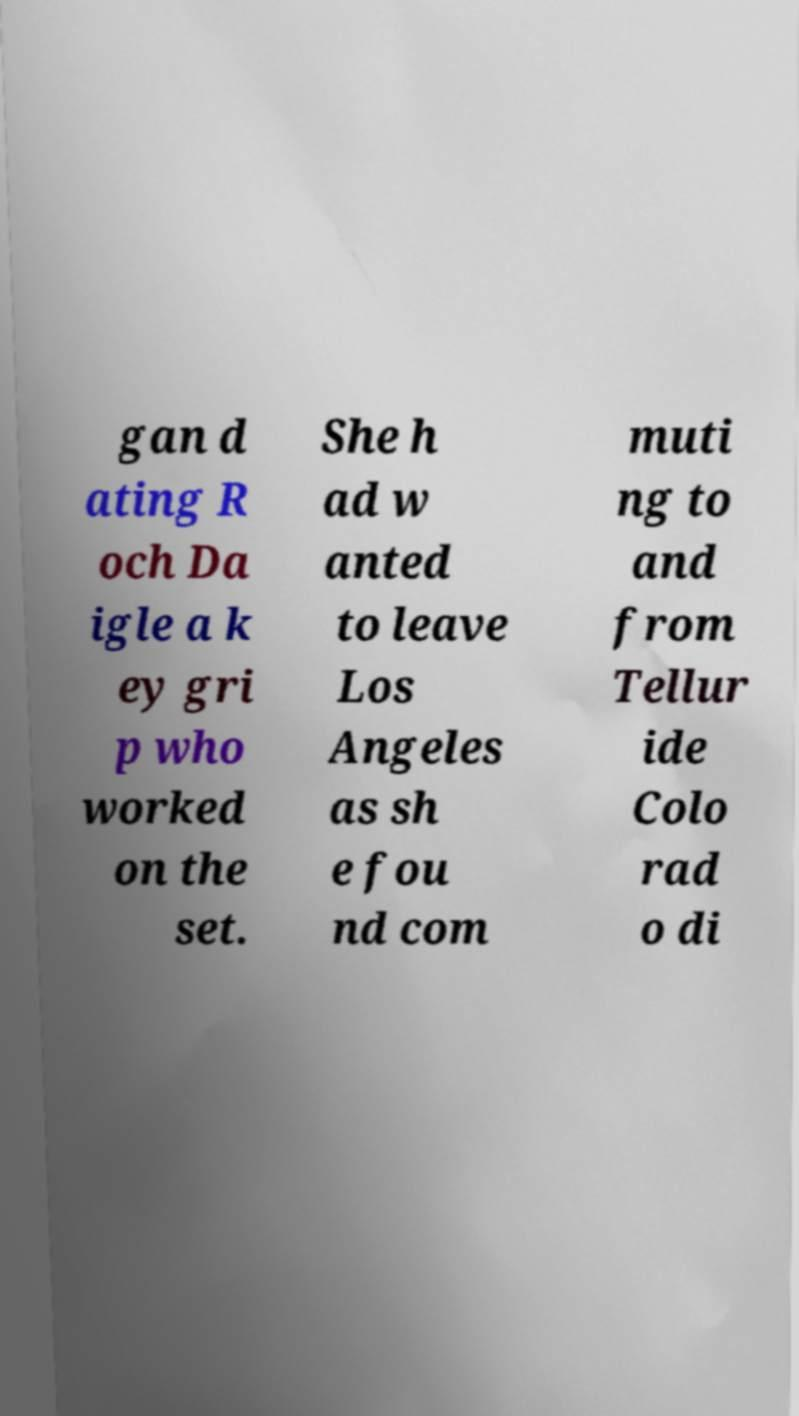Can you read and provide the text displayed in the image?This photo seems to have some interesting text. Can you extract and type it out for me? gan d ating R och Da igle a k ey gri p who worked on the set. She h ad w anted to leave Los Angeles as sh e fou nd com muti ng to and from Tellur ide Colo rad o di 